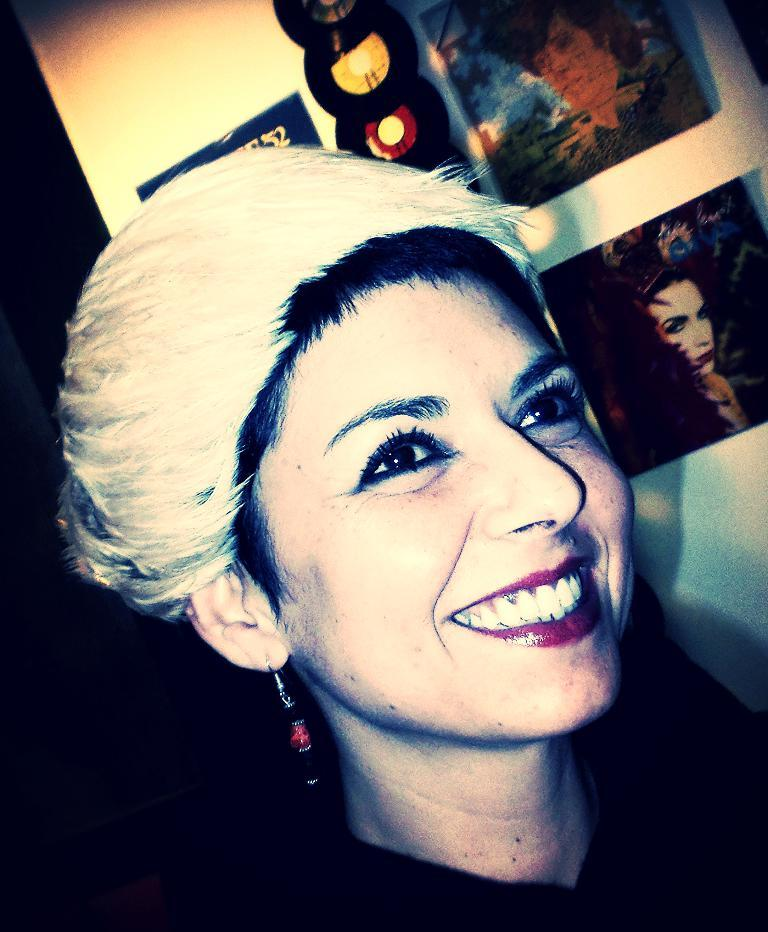Who is present in the image? There is a lady in the image. What is the lady doing in the image? The lady is smiling in the image. What can be seen in the background of the image? There are pictures and CDs on the wall in the background. What type of company is the lady representing in the image? There is no indication in the image that the lady is representing a company. How does the lady blow out the candles on her birthday cake in the image? There is no birthday cake or candles present in the image, so it is not possible to answer that question. 